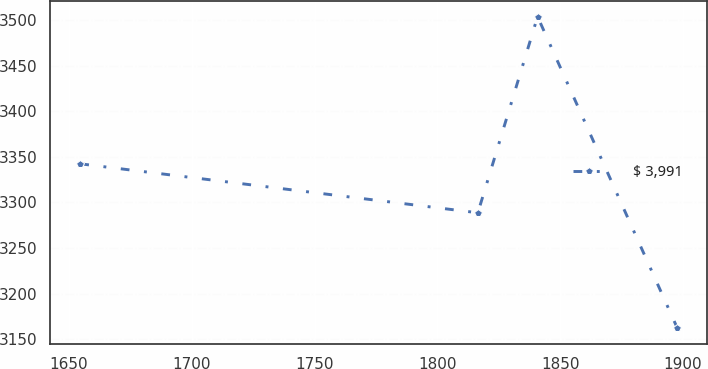<chart> <loc_0><loc_0><loc_500><loc_500><line_chart><ecel><fcel>$ 3,991<nl><fcel>1654.61<fcel>3342.41<nl><fcel>1816.48<fcel>3288.7<nl><fcel>1840.79<fcel>3503.83<nl><fcel>1897.71<fcel>3162.03<nl></chart> 